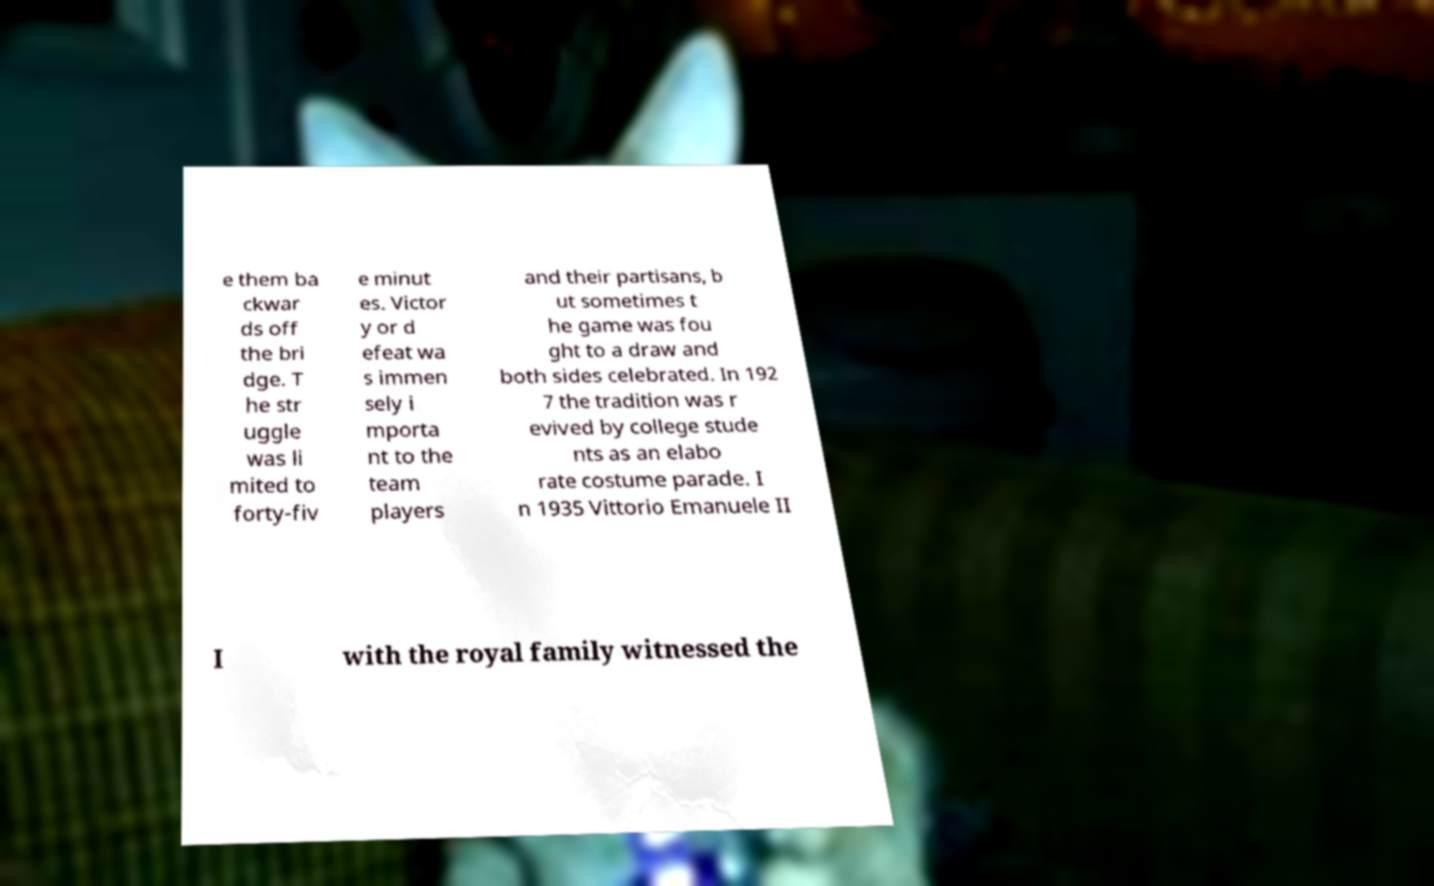For documentation purposes, I need the text within this image transcribed. Could you provide that? e them ba ckwar ds off the bri dge. T he str uggle was li mited to forty-fiv e minut es. Victor y or d efeat wa s immen sely i mporta nt to the team players and their partisans, b ut sometimes t he game was fou ght to a draw and both sides celebrated. In 192 7 the tradition was r evived by college stude nts as an elabo rate costume parade. I n 1935 Vittorio Emanuele II I with the royal family witnessed the 